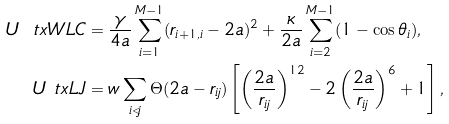Convert formula to latex. <formula><loc_0><loc_0><loc_500><loc_500>U _ { \ } t x { W L C } & = \frac { \gamma } { 4 a } \sum _ { i = 1 } ^ { M - 1 } ( r _ { i + 1 , i } - 2 a ) ^ { 2 } + \frac { \kappa } { 2 a } \sum _ { i = 2 } ^ { M - 1 } ( 1 - \cos \theta _ { i } ) , \\ U _ { \ } t x { L J } & = w \sum _ { i < j } \Theta ( 2 a - r _ { i j } ) \left [ \left ( \frac { 2 a } { r _ { i j } } \right ) ^ { 1 2 } - 2 \left ( \frac { 2 a } { r _ { i j } } \right ) ^ { 6 } + 1 \right ] ,</formula> 